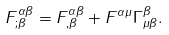Convert formula to latex. <formula><loc_0><loc_0><loc_500><loc_500>F _ { ; \beta } ^ { \alpha \beta } = F _ { , \beta } ^ { \alpha \beta } + F ^ { \alpha \mu } \Gamma _ { \mu \beta } ^ { \beta } .</formula> 